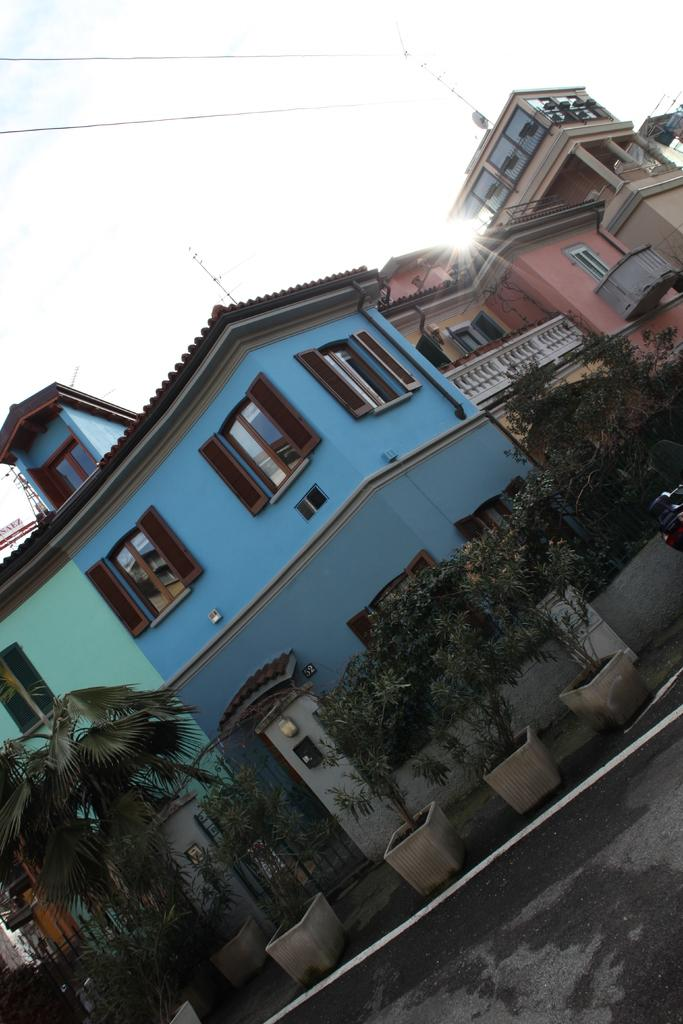What type of pathway can be seen in the image? There is a road in the image. What objects are present near the road? There are flower pots and a gate visible in the image. What type of barrier is present in the image? There is a fence in the image. What else can be seen in the image besides the road and fence? A vehicle and buildings are present in the image. Are there any wires visible in the image? Yes, wires are visible in the image. What can be seen in the background of the image? The sky is visible in the background of the image. How many trees are visible in the image? There are no trees visible in the image. What type of coat is the flower pot wearing in the image? Flower pots do not wear coats, as they are inanimate objects. 